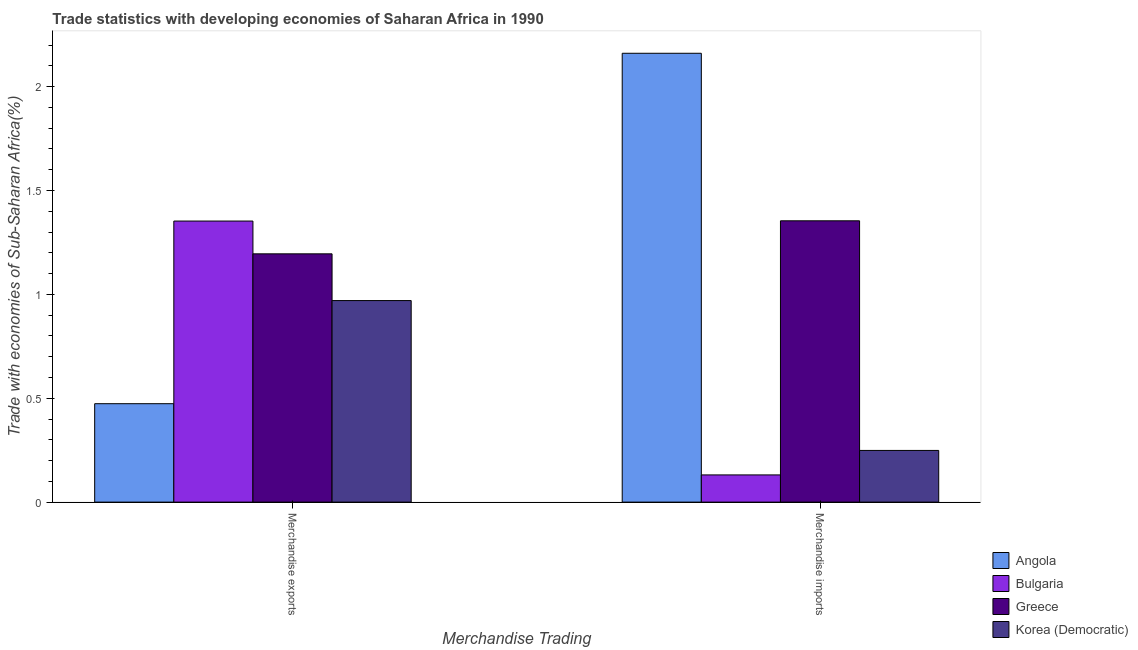How many different coloured bars are there?
Your response must be concise. 4. How many groups of bars are there?
Offer a very short reply. 2. How many bars are there on the 1st tick from the left?
Give a very brief answer. 4. How many bars are there on the 1st tick from the right?
Ensure brevity in your answer.  4. What is the label of the 1st group of bars from the left?
Your answer should be compact. Merchandise exports. What is the merchandise exports in Angola?
Provide a succinct answer. 0.47. Across all countries, what is the maximum merchandise exports?
Make the answer very short. 1.35. Across all countries, what is the minimum merchandise imports?
Offer a very short reply. 0.13. In which country was the merchandise exports maximum?
Your answer should be compact. Bulgaria. What is the total merchandise exports in the graph?
Offer a terse response. 3.99. What is the difference between the merchandise imports in Angola and that in Korea (Democratic)?
Offer a very short reply. 1.91. What is the difference between the merchandise imports in Bulgaria and the merchandise exports in Angola?
Provide a short and direct response. -0.34. What is the average merchandise exports per country?
Your answer should be compact. 1. What is the difference between the merchandise imports and merchandise exports in Korea (Democratic)?
Provide a succinct answer. -0.72. What is the ratio of the merchandise imports in Greece to that in Korea (Democratic)?
Make the answer very short. 5.44. Is the merchandise imports in Bulgaria less than that in Angola?
Your answer should be very brief. Yes. In how many countries, is the merchandise exports greater than the average merchandise exports taken over all countries?
Your answer should be very brief. 2. What does the 1st bar from the left in Merchandise imports represents?
Give a very brief answer. Angola. What does the 3rd bar from the right in Merchandise imports represents?
Provide a succinct answer. Bulgaria. Are all the bars in the graph horizontal?
Give a very brief answer. No. How many countries are there in the graph?
Offer a very short reply. 4. What is the difference between two consecutive major ticks on the Y-axis?
Give a very brief answer. 0.5. Are the values on the major ticks of Y-axis written in scientific E-notation?
Your response must be concise. No. Does the graph contain any zero values?
Make the answer very short. No. Does the graph contain grids?
Your answer should be compact. No. What is the title of the graph?
Give a very brief answer. Trade statistics with developing economies of Saharan Africa in 1990. Does "Pakistan" appear as one of the legend labels in the graph?
Give a very brief answer. No. What is the label or title of the X-axis?
Provide a short and direct response. Merchandise Trading. What is the label or title of the Y-axis?
Keep it short and to the point. Trade with economies of Sub-Saharan Africa(%). What is the Trade with economies of Sub-Saharan Africa(%) of Angola in Merchandise exports?
Your answer should be very brief. 0.47. What is the Trade with economies of Sub-Saharan Africa(%) of Bulgaria in Merchandise exports?
Ensure brevity in your answer.  1.35. What is the Trade with economies of Sub-Saharan Africa(%) in Greece in Merchandise exports?
Your response must be concise. 1.2. What is the Trade with economies of Sub-Saharan Africa(%) of Korea (Democratic) in Merchandise exports?
Your answer should be compact. 0.97. What is the Trade with economies of Sub-Saharan Africa(%) of Angola in Merchandise imports?
Provide a succinct answer. 2.16. What is the Trade with economies of Sub-Saharan Africa(%) of Bulgaria in Merchandise imports?
Give a very brief answer. 0.13. What is the Trade with economies of Sub-Saharan Africa(%) of Greece in Merchandise imports?
Your answer should be compact. 1.35. What is the Trade with economies of Sub-Saharan Africa(%) in Korea (Democratic) in Merchandise imports?
Give a very brief answer. 0.25. Across all Merchandise Trading, what is the maximum Trade with economies of Sub-Saharan Africa(%) of Angola?
Your answer should be very brief. 2.16. Across all Merchandise Trading, what is the maximum Trade with economies of Sub-Saharan Africa(%) of Bulgaria?
Offer a very short reply. 1.35. Across all Merchandise Trading, what is the maximum Trade with economies of Sub-Saharan Africa(%) in Greece?
Your response must be concise. 1.35. Across all Merchandise Trading, what is the maximum Trade with economies of Sub-Saharan Africa(%) in Korea (Democratic)?
Provide a short and direct response. 0.97. Across all Merchandise Trading, what is the minimum Trade with economies of Sub-Saharan Africa(%) in Angola?
Keep it short and to the point. 0.47. Across all Merchandise Trading, what is the minimum Trade with economies of Sub-Saharan Africa(%) of Bulgaria?
Make the answer very short. 0.13. Across all Merchandise Trading, what is the minimum Trade with economies of Sub-Saharan Africa(%) in Greece?
Make the answer very short. 1.2. Across all Merchandise Trading, what is the minimum Trade with economies of Sub-Saharan Africa(%) of Korea (Democratic)?
Your response must be concise. 0.25. What is the total Trade with economies of Sub-Saharan Africa(%) of Angola in the graph?
Your answer should be compact. 2.63. What is the total Trade with economies of Sub-Saharan Africa(%) of Bulgaria in the graph?
Provide a short and direct response. 1.48. What is the total Trade with economies of Sub-Saharan Africa(%) in Greece in the graph?
Provide a short and direct response. 2.55. What is the total Trade with economies of Sub-Saharan Africa(%) of Korea (Democratic) in the graph?
Provide a short and direct response. 1.22. What is the difference between the Trade with economies of Sub-Saharan Africa(%) of Angola in Merchandise exports and that in Merchandise imports?
Ensure brevity in your answer.  -1.69. What is the difference between the Trade with economies of Sub-Saharan Africa(%) in Bulgaria in Merchandise exports and that in Merchandise imports?
Your answer should be compact. 1.22. What is the difference between the Trade with economies of Sub-Saharan Africa(%) in Greece in Merchandise exports and that in Merchandise imports?
Your response must be concise. -0.16. What is the difference between the Trade with economies of Sub-Saharan Africa(%) in Korea (Democratic) in Merchandise exports and that in Merchandise imports?
Provide a short and direct response. 0.72. What is the difference between the Trade with economies of Sub-Saharan Africa(%) of Angola in Merchandise exports and the Trade with economies of Sub-Saharan Africa(%) of Bulgaria in Merchandise imports?
Keep it short and to the point. 0.34. What is the difference between the Trade with economies of Sub-Saharan Africa(%) in Angola in Merchandise exports and the Trade with economies of Sub-Saharan Africa(%) in Greece in Merchandise imports?
Keep it short and to the point. -0.88. What is the difference between the Trade with economies of Sub-Saharan Africa(%) of Angola in Merchandise exports and the Trade with economies of Sub-Saharan Africa(%) of Korea (Democratic) in Merchandise imports?
Keep it short and to the point. 0.23. What is the difference between the Trade with economies of Sub-Saharan Africa(%) in Bulgaria in Merchandise exports and the Trade with economies of Sub-Saharan Africa(%) in Greece in Merchandise imports?
Provide a short and direct response. -0. What is the difference between the Trade with economies of Sub-Saharan Africa(%) in Bulgaria in Merchandise exports and the Trade with economies of Sub-Saharan Africa(%) in Korea (Democratic) in Merchandise imports?
Provide a succinct answer. 1.1. What is the difference between the Trade with economies of Sub-Saharan Africa(%) in Greece in Merchandise exports and the Trade with economies of Sub-Saharan Africa(%) in Korea (Democratic) in Merchandise imports?
Provide a short and direct response. 0.95. What is the average Trade with economies of Sub-Saharan Africa(%) in Angola per Merchandise Trading?
Provide a short and direct response. 1.32. What is the average Trade with economies of Sub-Saharan Africa(%) of Bulgaria per Merchandise Trading?
Your answer should be compact. 0.74. What is the average Trade with economies of Sub-Saharan Africa(%) in Greece per Merchandise Trading?
Offer a terse response. 1.27. What is the average Trade with economies of Sub-Saharan Africa(%) in Korea (Democratic) per Merchandise Trading?
Your answer should be compact. 0.61. What is the difference between the Trade with economies of Sub-Saharan Africa(%) in Angola and Trade with economies of Sub-Saharan Africa(%) in Bulgaria in Merchandise exports?
Make the answer very short. -0.88. What is the difference between the Trade with economies of Sub-Saharan Africa(%) in Angola and Trade with economies of Sub-Saharan Africa(%) in Greece in Merchandise exports?
Your answer should be very brief. -0.72. What is the difference between the Trade with economies of Sub-Saharan Africa(%) of Angola and Trade with economies of Sub-Saharan Africa(%) of Korea (Democratic) in Merchandise exports?
Your answer should be compact. -0.5. What is the difference between the Trade with economies of Sub-Saharan Africa(%) in Bulgaria and Trade with economies of Sub-Saharan Africa(%) in Greece in Merchandise exports?
Your response must be concise. 0.16. What is the difference between the Trade with economies of Sub-Saharan Africa(%) in Bulgaria and Trade with economies of Sub-Saharan Africa(%) in Korea (Democratic) in Merchandise exports?
Make the answer very short. 0.38. What is the difference between the Trade with economies of Sub-Saharan Africa(%) in Greece and Trade with economies of Sub-Saharan Africa(%) in Korea (Democratic) in Merchandise exports?
Offer a terse response. 0.23. What is the difference between the Trade with economies of Sub-Saharan Africa(%) in Angola and Trade with economies of Sub-Saharan Africa(%) in Bulgaria in Merchandise imports?
Provide a short and direct response. 2.03. What is the difference between the Trade with economies of Sub-Saharan Africa(%) of Angola and Trade with economies of Sub-Saharan Africa(%) of Greece in Merchandise imports?
Provide a succinct answer. 0.81. What is the difference between the Trade with economies of Sub-Saharan Africa(%) of Angola and Trade with economies of Sub-Saharan Africa(%) of Korea (Democratic) in Merchandise imports?
Make the answer very short. 1.91. What is the difference between the Trade with economies of Sub-Saharan Africa(%) of Bulgaria and Trade with economies of Sub-Saharan Africa(%) of Greece in Merchandise imports?
Give a very brief answer. -1.22. What is the difference between the Trade with economies of Sub-Saharan Africa(%) of Bulgaria and Trade with economies of Sub-Saharan Africa(%) of Korea (Democratic) in Merchandise imports?
Make the answer very short. -0.12. What is the difference between the Trade with economies of Sub-Saharan Africa(%) of Greece and Trade with economies of Sub-Saharan Africa(%) of Korea (Democratic) in Merchandise imports?
Offer a terse response. 1.11. What is the ratio of the Trade with economies of Sub-Saharan Africa(%) of Angola in Merchandise exports to that in Merchandise imports?
Provide a short and direct response. 0.22. What is the ratio of the Trade with economies of Sub-Saharan Africa(%) in Bulgaria in Merchandise exports to that in Merchandise imports?
Keep it short and to the point. 10.33. What is the ratio of the Trade with economies of Sub-Saharan Africa(%) of Greece in Merchandise exports to that in Merchandise imports?
Make the answer very short. 0.88. What is the ratio of the Trade with economies of Sub-Saharan Africa(%) in Korea (Democratic) in Merchandise exports to that in Merchandise imports?
Make the answer very short. 3.9. What is the difference between the highest and the second highest Trade with economies of Sub-Saharan Africa(%) in Angola?
Keep it short and to the point. 1.69. What is the difference between the highest and the second highest Trade with economies of Sub-Saharan Africa(%) of Bulgaria?
Provide a short and direct response. 1.22. What is the difference between the highest and the second highest Trade with economies of Sub-Saharan Africa(%) in Greece?
Make the answer very short. 0.16. What is the difference between the highest and the second highest Trade with economies of Sub-Saharan Africa(%) in Korea (Democratic)?
Provide a succinct answer. 0.72. What is the difference between the highest and the lowest Trade with economies of Sub-Saharan Africa(%) of Angola?
Your answer should be very brief. 1.69. What is the difference between the highest and the lowest Trade with economies of Sub-Saharan Africa(%) in Bulgaria?
Your answer should be very brief. 1.22. What is the difference between the highest and the lowest Trade with economies of Sub-Saharan Africa(%) in Greece?
Offer a very short reply. 0.16. What is the difference between the highest and the lowest Trade with economies of Sub-Saharan Africa(%) of Korea (Democratic)?
Offer a terse response. 0.72. 